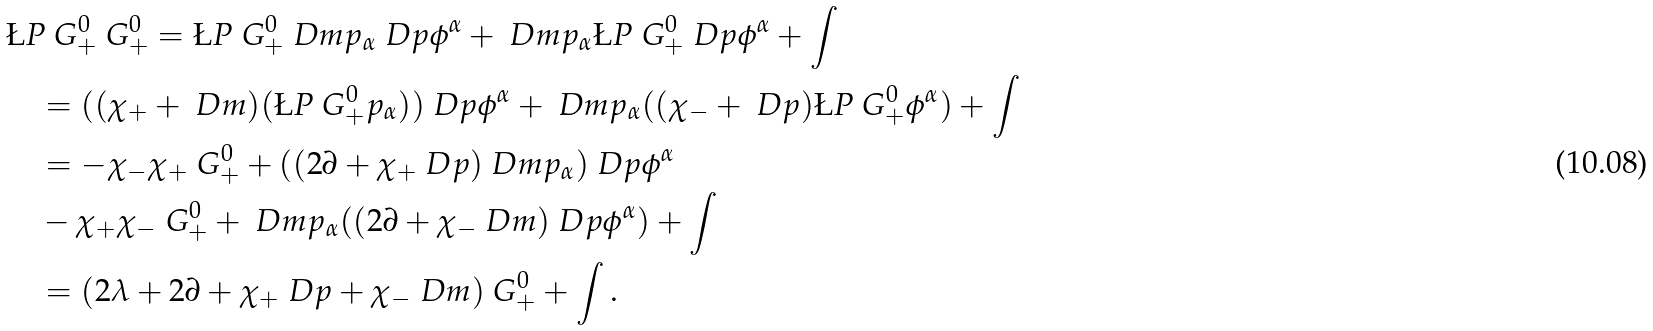<formula> <loc_0><loc_0><loc_500><loc_500>& \L P { \ G ^ { 0 } _ { + } } { \ G ^ { 0 } _ { + } } = \L P { \ G ^ { 0 } _ { + } } { \ D m p _ { \alpha } } \ D p \phi ^ { \alpha } + \ D m p _ { \alpha } \L P { \ G ^ { 0 } _ { + } } { \ D p \phi ^ { \alpha } } + \int \\ & \quad = ( ( \chi _ { + } + \ D m ) ( \L P { \ G ^ { 0 } _ { + } } { p _ { \alpha } } ) ) \ D p \phi ^ { \alpha } + \ D m p _ { \alpha } ( ( \chi _ { - } + \ D p ) \L P { \ G ^ { 0 } _ { + } } { \phi ^ { \alpha } } ) + \int \\ & \quad = - \chi _ { - } \chi _ { + } \ G ^ { 0 } _ { + } + ( ( 2 \partial + \chi _ { + } \ D p ) \ D m p _ { \alpha } ) \ D p \phi ^ { \alpha } \\ & \quad - \chi _ { + } \chi _ { - } \ G ^ { 0 } _ { + } + \ D m p _ { \alpha } ( ( 2 \partial + \chi _ { - } \ D m ) \ D p \phi ^ { \alpha } ) + \int \\ & \quad = ( 2 \lambda + 2 \partial + \chi _ { + } \ D p + \chi _ { - } \ D m ) \ G ^ { 0 } _ { + } + \int .</formula> 